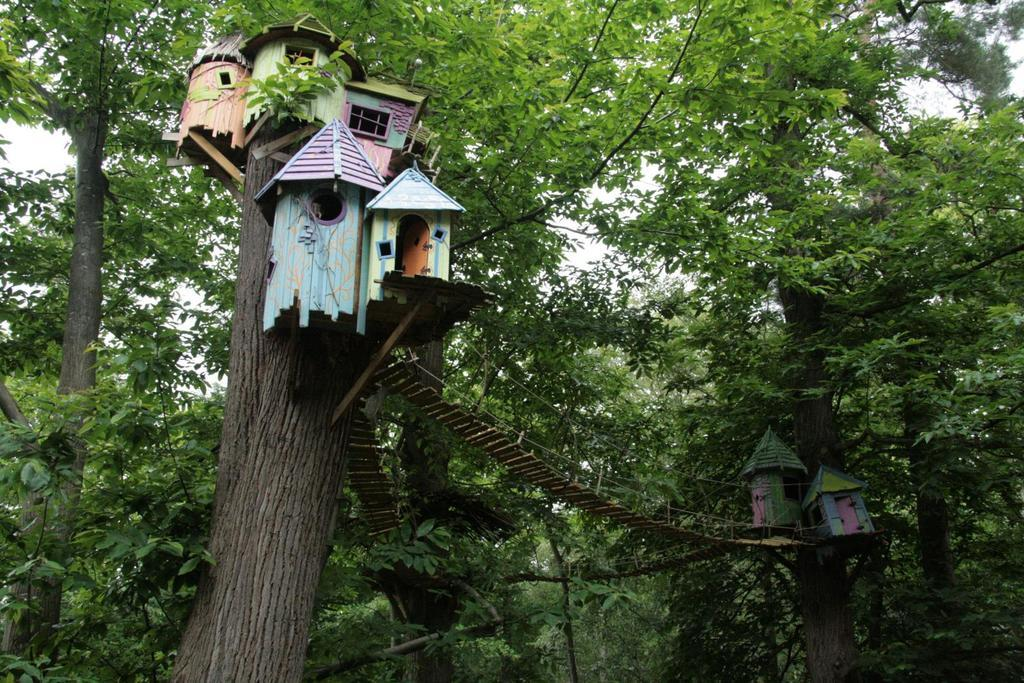What type of structures are present in the image? There are tree houses in the image. How are the tree houses connected? There is a wooden bridge connecting the tree houses. What can be seen in the background of the image? There are many trees in the image. What part of the natural environment is visible in the image? Some part of the sky is visible in the image. Where is the girl standing on the edge of the ground in the image? There is no girl present in the image, and therefore no one is standing on the edge of the ground. 